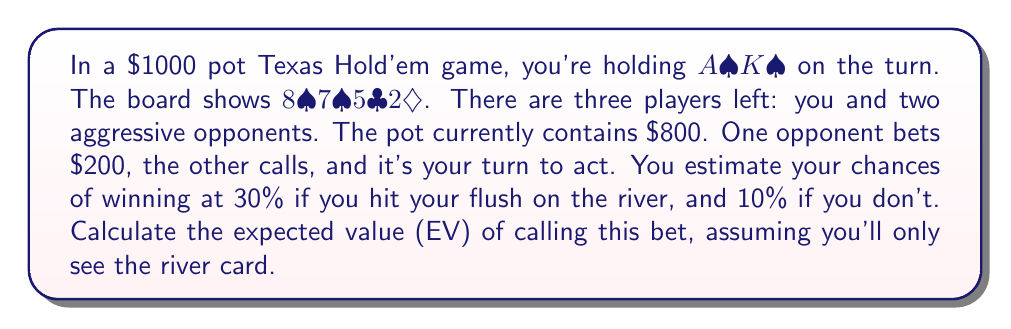Give your solution to this math problem. To calculate the expected value (EV) of calling, we need to follow these steps:

1. Calculate the pot odds:
   Current pot: $800 + $200 + $200 = $1200
   Your call: $200
   Pot odds = $200 : $1200 = 1 : 6 = 0.1667 or 16.67%

2. Calculate the probability of hitting the flush:
   9 remaining spades out of 46 unseen cards = 9/46 ≈ 0.1957 or 19.57%

3. Calculate the EV of calling and hitting the flush:
   Probability: 0.1957
   Win rate: 30%
   Pot if won: $1400
   EV(hit) = 0.1957 * 0.30 * $1400 = $82.19

4. Calculate the EV of calling and not hitting the flush:
   Probability: 1 - 0.1957 = 0.8043
   Win rate: 10%
   Pot if won: $1400
   EV(miss) = 0.8043 * 0.10 * $1400 = $112.60

5. Calculate the total EV:
   EV(total) = EV(hit) + EV(miss) - Call amount
   EV(total) = $82.19 + $112.60 - $200 = -$5.21

The negative EV suggests that calling is not profitable in the long run.
Answer: $-$5.21 